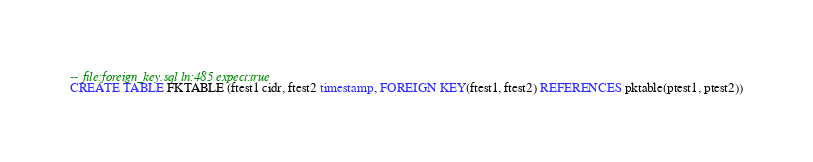Convert code to text. <code><loc_0><loc_0><loc_500><loc_500><_SQL_>-- file:foreign_key.sql ln:485 expect:true
CREATE TABLE FKTABLE (ftest1 cidr, ftest2 timestamp, FOREIGN KEY(ftest1, ftest2) REFERENCES pktable(ptest1, ptest2))
</code> 